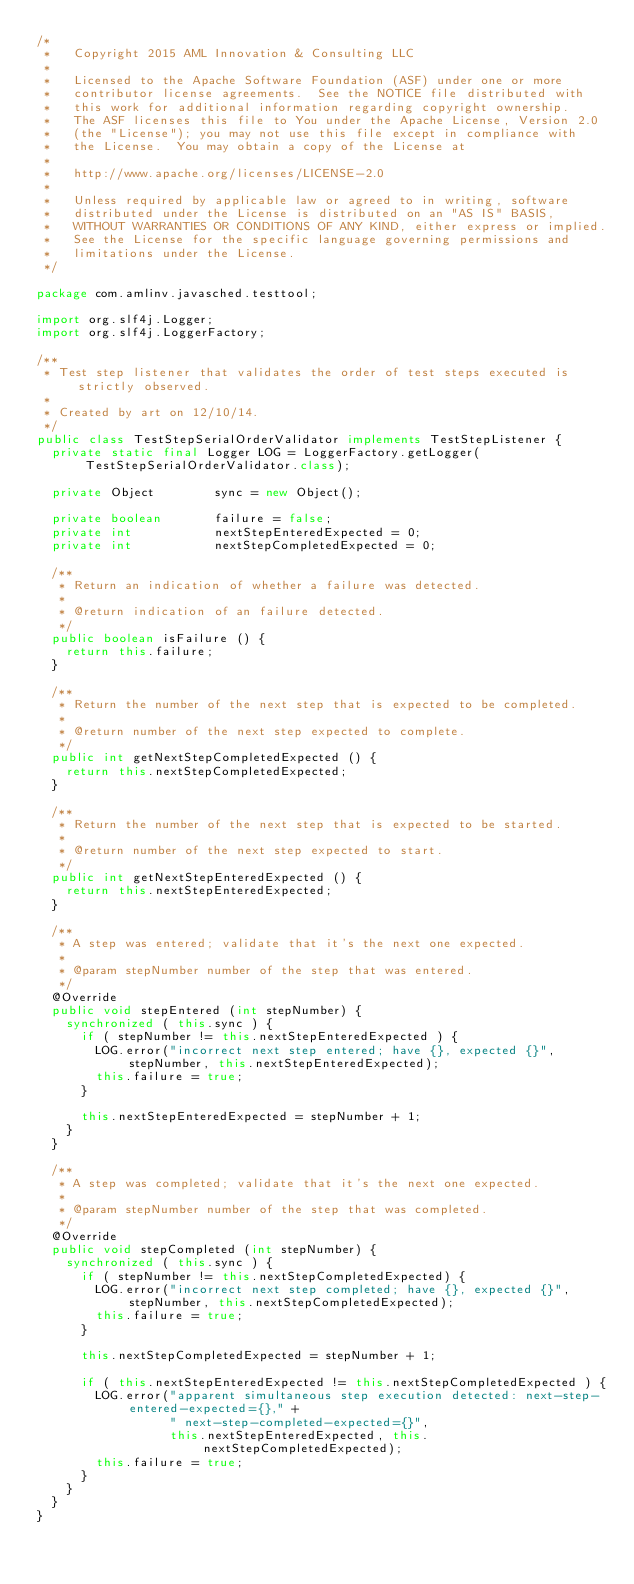<code> <loc_0><loc_0><loc_500><loc_500><_Java_>/*
 *   Copyright 2015 AML Innovation & Consulting LLC
 *
 *   Licensed to the Apache Software Foundation (ASF) under one or more
 *   contributor license agreements.  See the NOTICE file distributed with
 *   this work for additional information regarding copyright ownership.
 *   The ASF licenses this file to You under the Apache License, Version 2.0
 *   (the "License"); you may not use this file except in compliance with
 *   the License.  You may obtain a copy of the License at
 *
 *   http://www.apache.org/licenses/LICENSE-2.0
 *
 *   Unless required by applicable law or agreed to in writing, software
 *   distributed under the License is distributed on an "AS IS" BASIS,
 *   WITHOUT WARRANTIES OR CONDITIONS OF ANY KIND, either express or implied.
 *   See the License for the specific language governing permissions and
 *   limitations under the License.
 */

package com.amlinv.javasched.testtool;

import org.slf4j.Logger;
import org.slf4j.LoggerFactory;

/**
 * Test step listener that validates the order of test steps executed is strictly observed.
 *
 * Created by art on 12/10/14.
 */
public class TestStepSerialOrderValidator implements TestStepListener {
  private static final Logger LOG = LoggerFactory.getLogger(TestStepSerialOrderValidator.class);

  private Object        sync = new Object();

  private boolean       failure = false;
  private int           nextStepEnteredExpected = 0;
  private int           nextStepCompletedExpected = 0;

  /**
   * Return an indication of whether a failure was detected.
   *
   * @return indication of an failure detected.
   */
  public boolean isFailure () {
    return this.failure;
  }

  /**
   * Return the number of the next step that is expected to be completed.
   *
   * @return number of the next step expected to complete.
   */
  public int getNextStepCompletedExpected () {
    return this.nextStepCompletedExpected;
  }

  /**
   * Return the number of the next step that is expected to be started.
   *
   * @return number of the next step expected to start.
   */
  public int getNextStepEnteredExpected () {
    return this.nextStepEnteredExpected;
  }

  /**
   * A step was entered; validate that it's the next one expected.
   *
   * @param stepNumber number of the step that was entered.
   */
  @Override
  public void stepEntered (int stepNumber) {
    synchronized ( this.sync ) {
      if ( stepNumber != this.nextStepEnteredExpected ) {
        LOG.error("incorrect next step entered; have {}, expected {}", stepNumber, this.nextStepEnteredExpected);
        this.failure = true;
      }

      this.nextStepEnteredExpected = stepNumber + 1;
    }
  }

  /**
   * A step was completed; validate that it's the next one expected.
   *
   * @param stepNumber number of the step that was completed.
   */
  @Override
  public void stepCompleted (int stepNumber) {
    synchronized ( this.sync ) {
      if ( stepNumber != this.nextStepCompletedExpected) {
        LOG.error("incorrect next step completed; have {}, expected {}", stepNumber, this.nextStepCompletedExpected);
        this.failure = true;
      }

      this.nextStepCompletedExpected = stepNumber + 1;

      if ( this.nextStepEnteredExpected != this.nextStepCompletedExpected ) {
        LOG.error("apparent simultaneous step execution detected: next-step-entered-expected={}," +
                  " next-step-completed-expected={}",
                  this.nextStepEnteredExpected, this.nextStepCompletedExpected);
        this.failure = true;
      }
    }
  }
}
</code> 